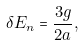Convert formula to latex. <formula><loc_0><loc_0><loc_500><loc_500>\delta E _ { n } = \frac { 3 g } { 2 a } ,</formula> 